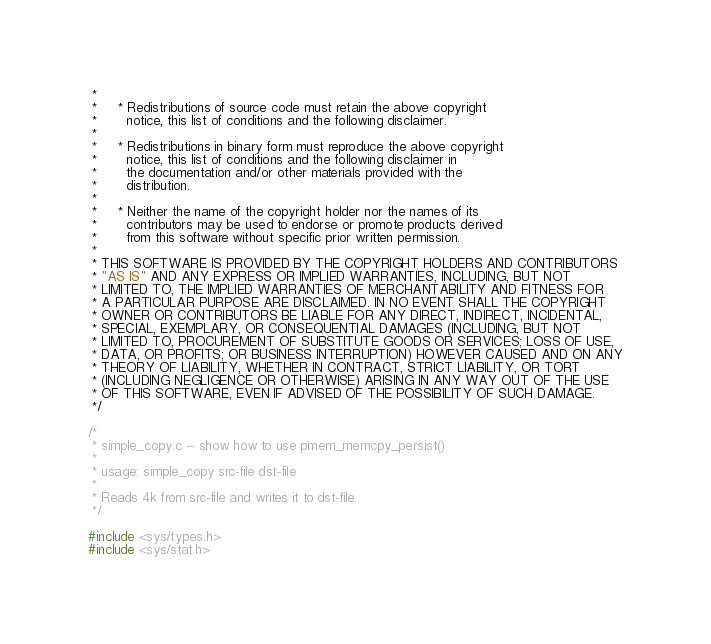Convert code to text. <code><loc_0><loc_0><loc_500><loc_500><_C_> *
 *     * Redistributions of source code must retain the above copyright
 *       notice, this list of conditions and the following disclaimer.
 *
 *     * Redistributions in binary form must reproduce the above copyright
 *       notice, this list of conditions and the following disclaimer in
 *       the documentation and/or other materials provided with the
 *       distribution.
 *
 *     * Neither the name of the copyright holder nor the names of its
 *       contributors may be used to endorse or promote products derived
 *       from this software without specific prior written permission.
 *
 * THIS SOFTWARE IS PROVIDED BY THE COPYRIGHT HOLDERS AND CONTRIBUTORS
 * "AS IS" AND ANY EXPRESS OR IMPLIED WARRANTIES, INCLUDING, BUT NOT
 * LIMITED TO, THE IMPLIED WARRANTIES OF MERCHANTABILITY AND FITNESS FOR
 * A PARTICULAR PURPOSE ARE DISCLAIMED. IN NO EVENT SHALL THE COPYRIGHT
 * OWNER OR CONTRIBUTORS BE LIABLE FOR ANY DIRECT, INDIRECT, INCIDENTAL,
 * SPECIAL, EXEMPLARY, OR CONSEQUENTIAL DAMAGES (INCLUDING, BUT NOT
 * LIMITED TO, PROCUREMENT OF SUBSTITUTE GOODS OR SERVICES; LOSS OF USE,
 * DATA, OR PROFITS; OR BUSINESS INTERRUPTION) HOWEVER CAUSED AND ON ANY
 * THEORY OF LIABILITY, WHETHER IN CONTRACT, STRICT LIABILITY, OR TORT
 * (INCLUDING NEGLIGENCE OR OTHERWISE) ARISING IN ANY WAY OUT OF THE USE
 * OF THIS SOFTWARE, EVEN IF ADVISED OF THE POSSIBILITY OF SUCH DAMAGE.
 */

/*
 * simple_copy.c -- show how to use pmem_memcpy_persist()
 *
 * usage: simple_copy src-file dst-file
 *
 * Reads 4k from src-file and writes it to dst-file.
 */

#include <sys/types.h>
#include <sys/stat.h></code> 